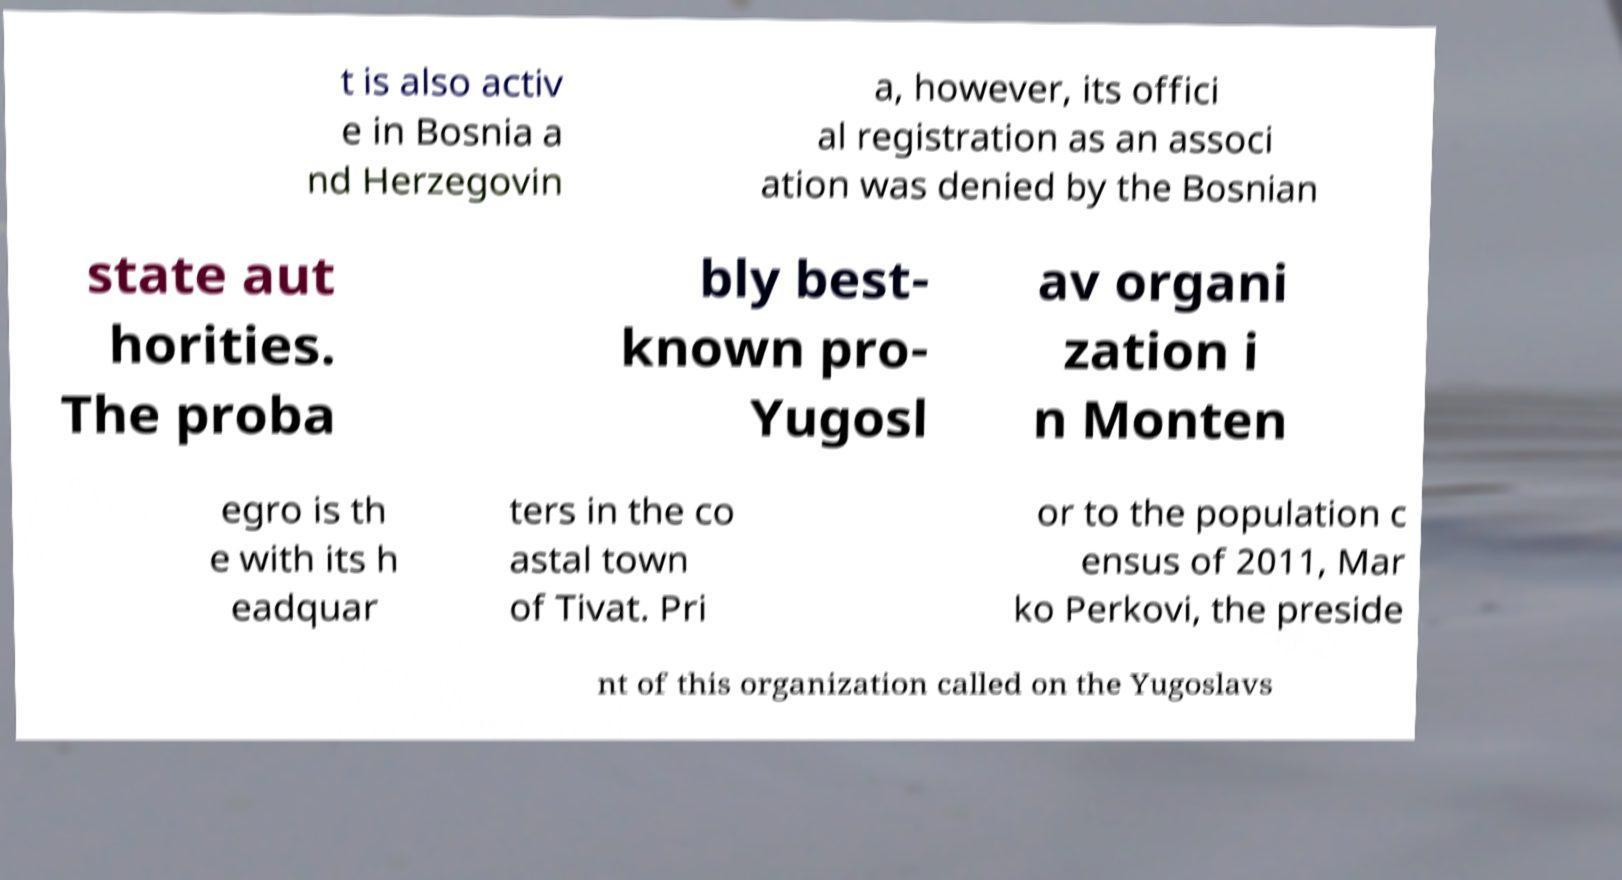Could you extract and type out the text from this image? t is also activ e in Bosnia a nd Herzegovin a, however, its offici al registration as an associ ation was denied by the Bosnian state aut horities. The proba bly best- known pro- Yugosl av organi zation i n Monten egro is th e with its h eadquar ters in the co astal town of Tivat. Pri or to the population c ensus of 2011, Mar ko Perkovi, the preside nt of this organization called on the Yugoslavs 